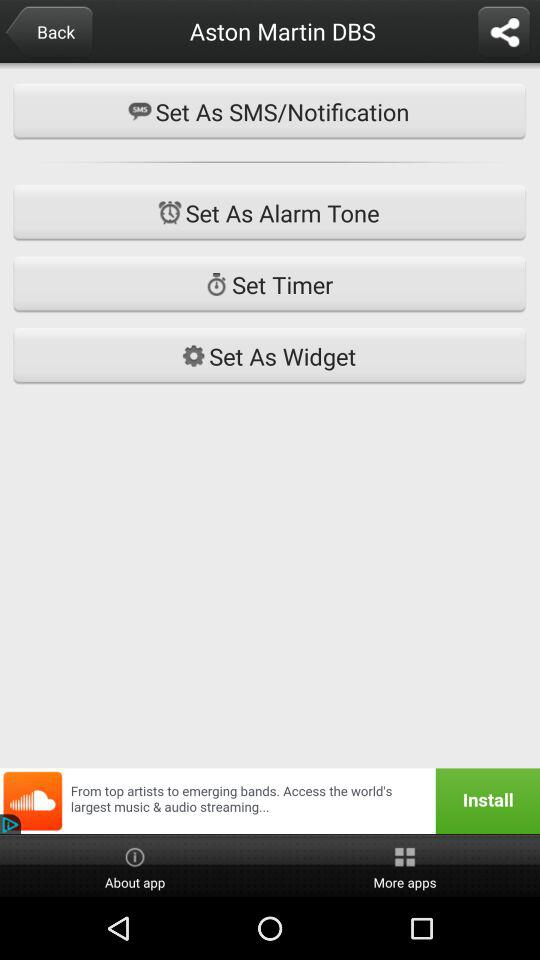What are the apps that can be used to share the content? The apps that can be used to share the content are "Facebook", "Slack", "BigOven", "iFunny", "Dict Box Arabic", "MemoWidget", "Messaging" and "Android Beam". 